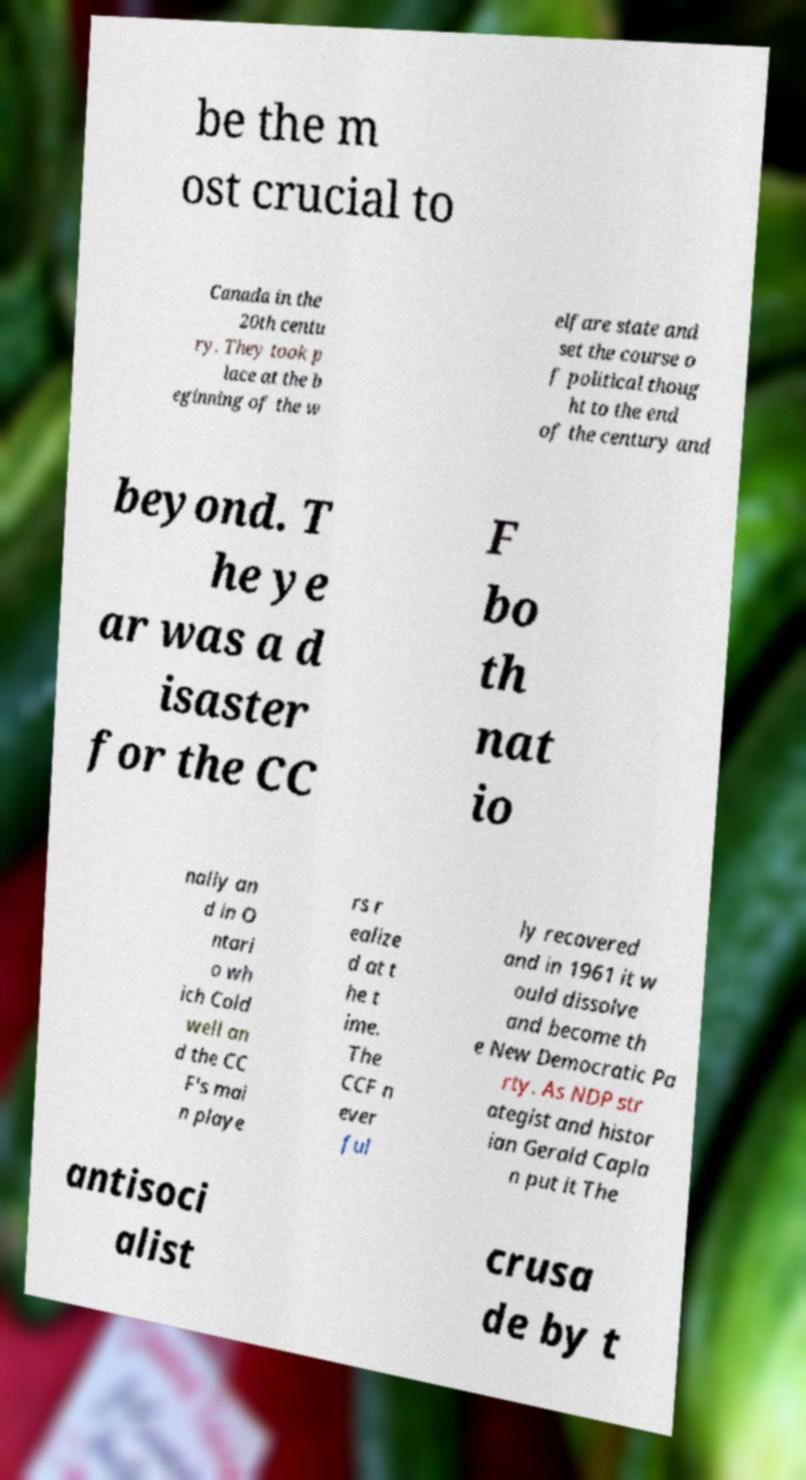There's text embedded in this image that I need extracted. Can you transcribe it verbatim? be the m ost crucial to Canada in the 20th centu ry. They took p lace at the b eginning of the w elfare state and set the course o f political thoug ht to the end of the century and beyond. T he ye ar was a d isaster for the CC F bo th nat io nally an d in O ntari o wh ich Cold well an d the CC F's mai n playe rs r ealize d at t he t ime. The CCF n ever ful ly recovered and in 1961 it w ould dissolve and become th e New Democratic Pa rty. As NDP str ategist and histor ian Gerald Capla n put it The antisoci alist crusa de by t 